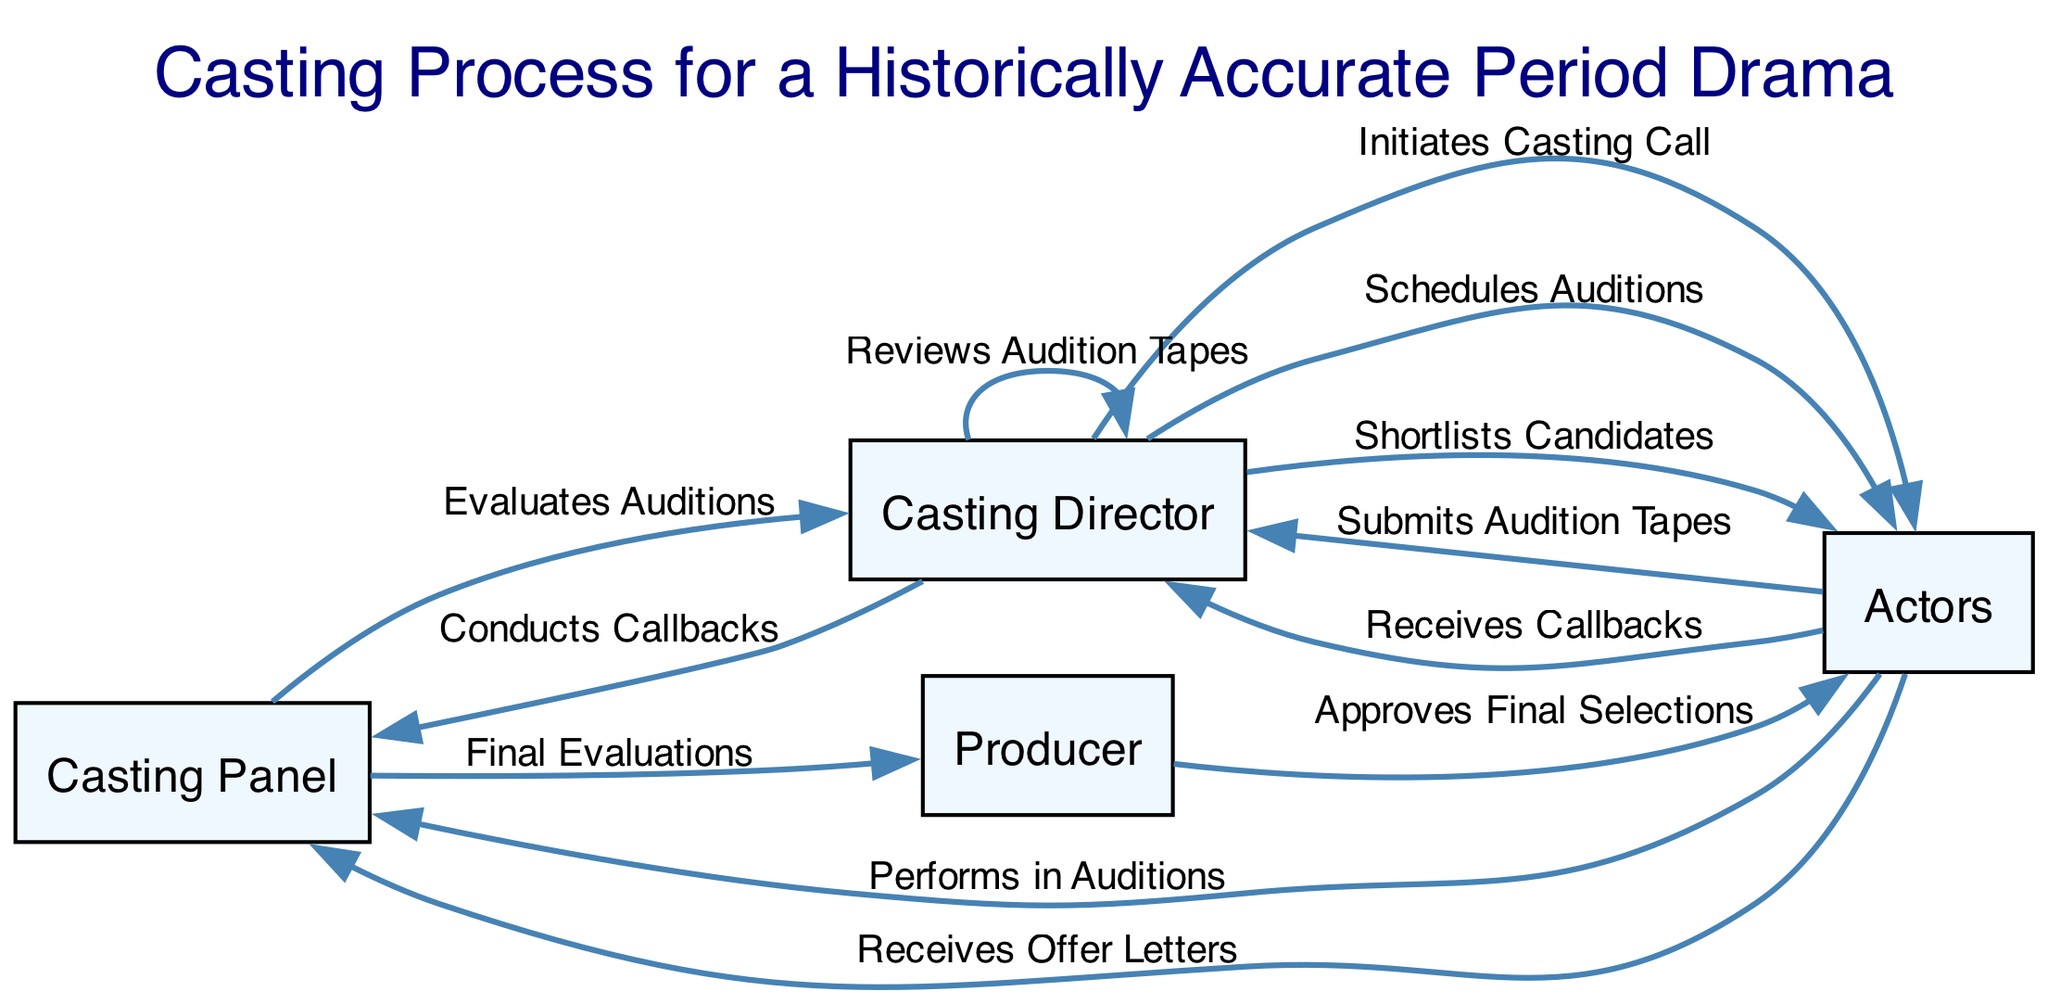What initiates the casting call process? The diagram shows that the "Casting Director" initiates the casting call process. This can be identified as the first action in the sequence of interactions depicted.
Answer: Casting Director How many steps are there between the initial casting call and the final selections? By counting the number of distinct actions in the sequence from "Initiates Casting Call" to "Approves Final Selections," we find there are several steps involved, including auditions and evaluations. The total is 11 actions.
Answer: 11 Who evaluates the auditions? The "Casting Panel" is responsible for evaluating auditions, as indicated in the step labeled "Evaluates Auditions." This follows the actors’ performances in auditions.
Answer: Casting Panel What action follows the submission of audition tapes? After "Actors" submit audition tapes, the next action is performed by the "Casting Director," who reviews the audition tapes. This illustrates the sequential nature of processing the submissions.
Answer: Reviews Audition Tapes Which role receives the offer letters? According to the final steps in the diagram, the "Actors" receive the offer letters after the producer approves the final selections. This indicates that actors are the recipients of the offers related to their roles.
Answer: Actors What is the last action in the casting process? The last action illustrated in the sequence is "Receives Offer Letters." This indicates that the casting process culminates with this action after several evaluation steps.
Answer: Receives Offer Letters How many times does the casting director appear in the sequence? By examining the actions in the diagram, we can see that the "Casting Director" appears multiple times; specifically, they are involved in four distinct actions throughout the process.
Answer: 4 Which participant conducts the callbacks? The "Casting Director" conducts the callbacks, as specified in the sequence after the actors receive their callbacks. This action highlights their continuing involvement in the selection process.
Answer: Conducts Callbacks What happens immediately after the casting director schedules auditions? Following the scheduling of auditions, the "Actors" perform in auditions, indicating a direct action that follows the schedule set by the casting director.
Answer: Performs in Auditions 